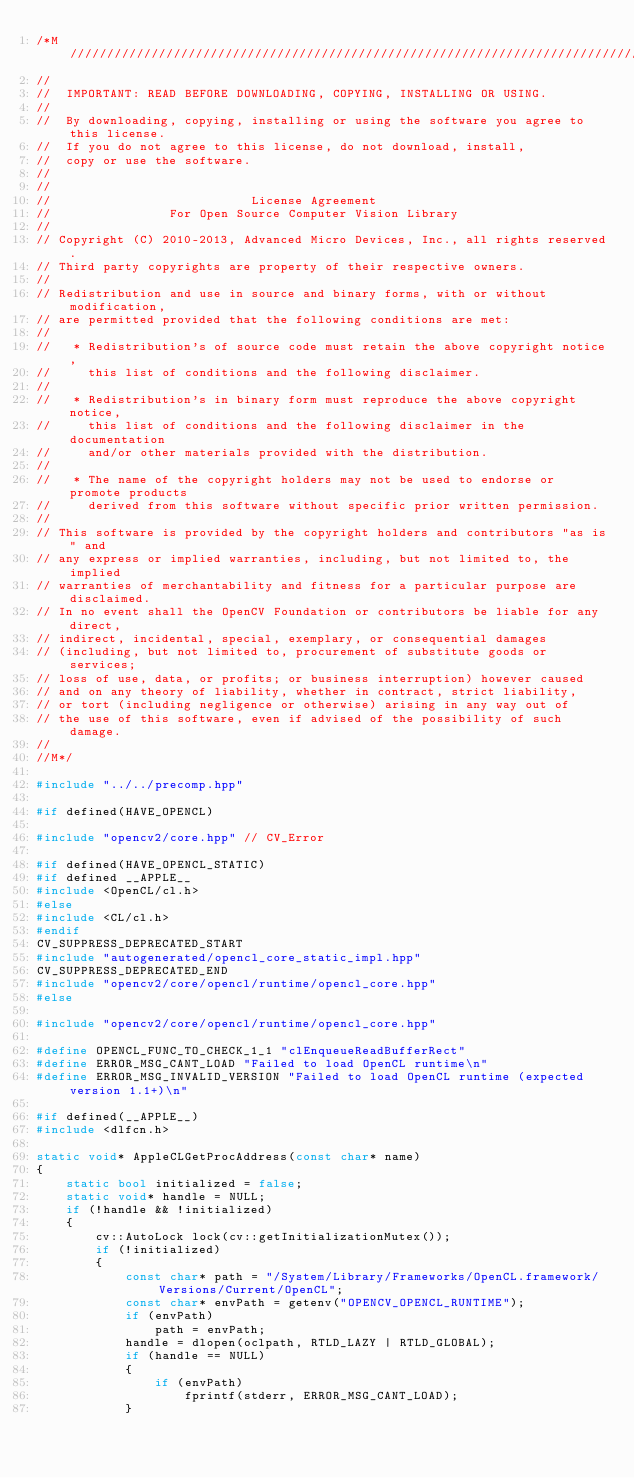<code> <loc_0><loc_0><loc_500><loc_500><_C++_>/*M///////////////////////////////////////////////////////////////////////////////////////
//
//  IMPORTANT: READ BEFORE DOWNLOADING, COPYING, INSTALLING OR USING.
//
//  By downloading, copying, installing or using the software you agree to this license.
//  If you do not agree to this license, do not download, install,
//  copy or use the software.
//
//
//                           License Agreement
//                For Open Source Computer Vision Library
//
// Copyright (C) 2010-2013, Advanced Micro Devices, Inc., all rights reserved.
// Third party copyrights are property of their respective owners.
//
// Redistribution and use in source and binary forms, with or without modification,
// are permitted provided that the following conditions are met:
//
//   * Redistribution's of source code must retain the above copyright notice,
//     this list of conditions and the following disclaimer.
//
//   * Redistribution's in binary form must reproduce the above copyright notice,
//     this list of conditions and the following disclaimer in the documentation
//     and/or other materials provided with the distribution.
//
//   * The name of the copyright holders may not be used to endorse or promote products
//     derived from this software without specific prior written permission.
//
// This software is provided by the copyright holders and contributors "as is" and
// any express or implied warranties, including, but not limited to, the implied
// warranties of merchantability and fitness for a particular purpose are disclaimed.
// In no event shall the OpenCV Foundation or contributors be liable for any direct,
// indirect, incidental, special, exemplary, or consequential damages
// (including, but not limited to, procurement of substitute goods or services;
// loss of use, data, or profits; or business interruption) however caused
// and on any theory of liability, whether in contract, strict liability,
// or tort (including negligence or otherwise) arising in any way out of
// the use of this software, even if advised of the possibility of such damage.
//
//M*/

#include "../../precomp.hpp"

#if defined(HAVE_OPENCL)

#include "opencv2/core.hpp" // CV_Error

#if defined(HAVE_OPENCL_STATIC)
#if defined __APPLE__
#include <OpenCL/cl.h>
#else
#include <CL/cl.h>
#endif
CV_SUPPRESS_DEPRECATED_START
#include "autogenerated/opencl_core_static_impl.hpp"
CV_SUPPRESS_DEPRECATED_END
#include "opencv2/core/opencl/runtime/opencl_core.hpp"
#else

#include "opencv2/core/opencl/runtime/opencl_core.hpp"

#define OPENCL_FUNC_TO_CHECK_1_1 "clEnqueueReadBufferRect"
#define ERROR_MSG_CANT_LOAD "Failed to load OpenCL runtime\n"
#define ERROR_MSG_INVALID_VERSION "Failed to load OpenCL runtime (expected version 1.1+)\n"

#if defined(__APPLE__)
#include <dlfcn.h>

static void* AppleCLGetProcAddress(const char* name)
{
    static bool initialized = false;
    static void* handle = NULL;
    if (!handle && !initialized)
    {
        cv::AutoLock lock(cv::getInitializationMutex());
        if (!initialized)
        {
            const char* path = "/System/Library/Frameworks/OpenCL.framework/Versions/Current/OpenCL";
            const char* envPath = getenv("OPENCV_OPENCL_RUNTIME");
            if (envPath)
                path = envPath;
            handle = dlopen(oclpath, RTLD_LAZY | RTLD_GLOBAL);
            if (handle == NULL)
            {
                if (envPath)
                    fprintf(stderr, ERROR_MSG_CANT_LOAD);
            }</code> 